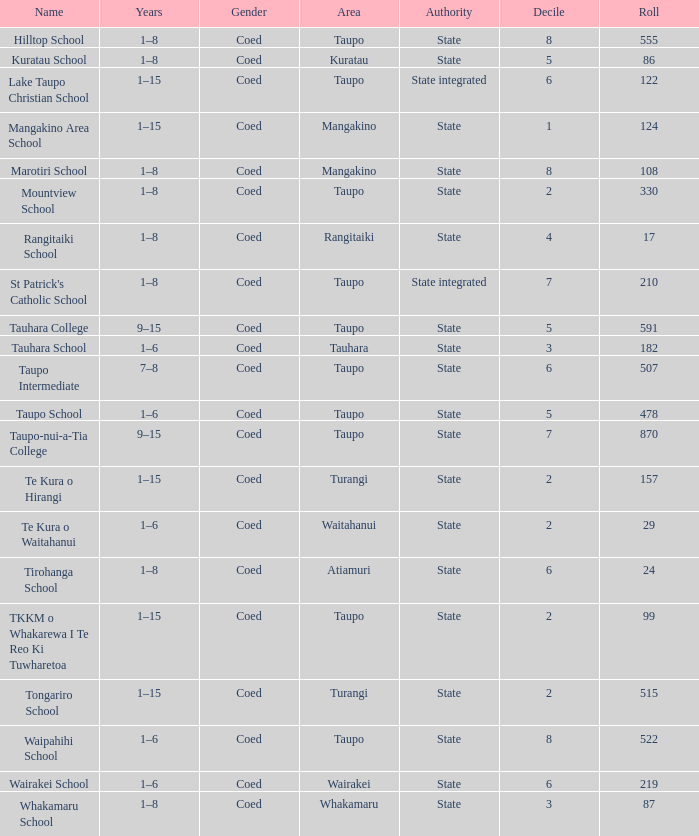What is the Whakamaru school's authority? State. 